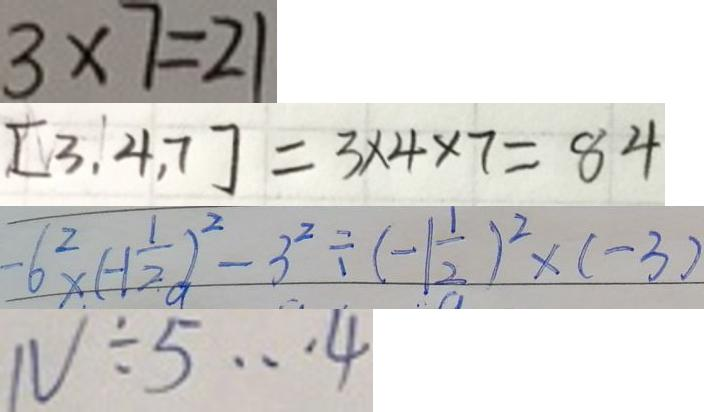Convert formula to latex. <formula><loc_0><loc_0><loc_500><loc_500>3 \times 7 = 2 1 
 [ 3 , 4 , 7 ] = 3 \times 4 \times 7 = 8 4 
 - 6 ^ { 2 } \times ( - 1 \frac { 1 } { 2 } ) ^ { 2 } - 3 ^ { 2 } \div ( - 1 \frac { 1 } { 2 } ) ^ { 2 } \times ( - 3 ) 
 N \div 5 \cdots 4</formula> 